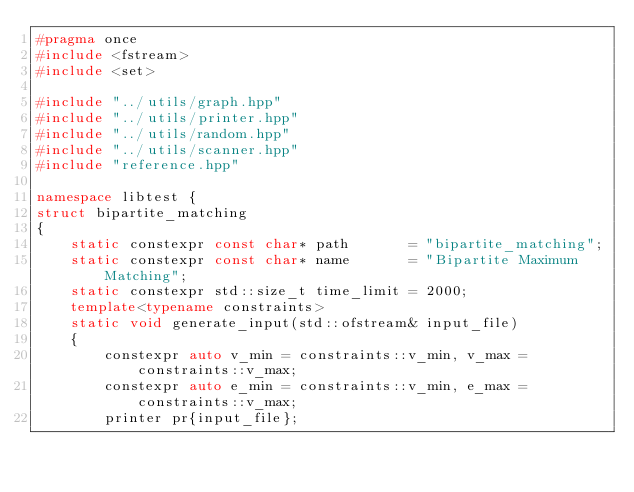<code> <loc_0><loc_0><loc_500><loc_500><_C++_>#pragma once
#include <fstream>
#include <set>

#include "../utils/graph.hpp"
#include "../utils/printer.hpp"
#include "../utils/random.hpp"
#include "../utils/scanner.hpp"
#include "reference.hpp"

namespace libtest {
struct bipartite_matching
{
    static constexpr const char* path       = "bipartite_matching";
    static constexpr const char* name       = "Bipartite Maximum Matching";
    static constexpr std::size_t time_limit = 2000;
    template<typename constraints>
    static void generate_input(std::ofstream& input_file)
    {
        constexpr auto v_min = constraints::v_min, v_max = constraints::v_max;
        constexpr auto e_min = constraints::v_min, e_max = constraints::v_max;
        printer pr{input_file};</code> 